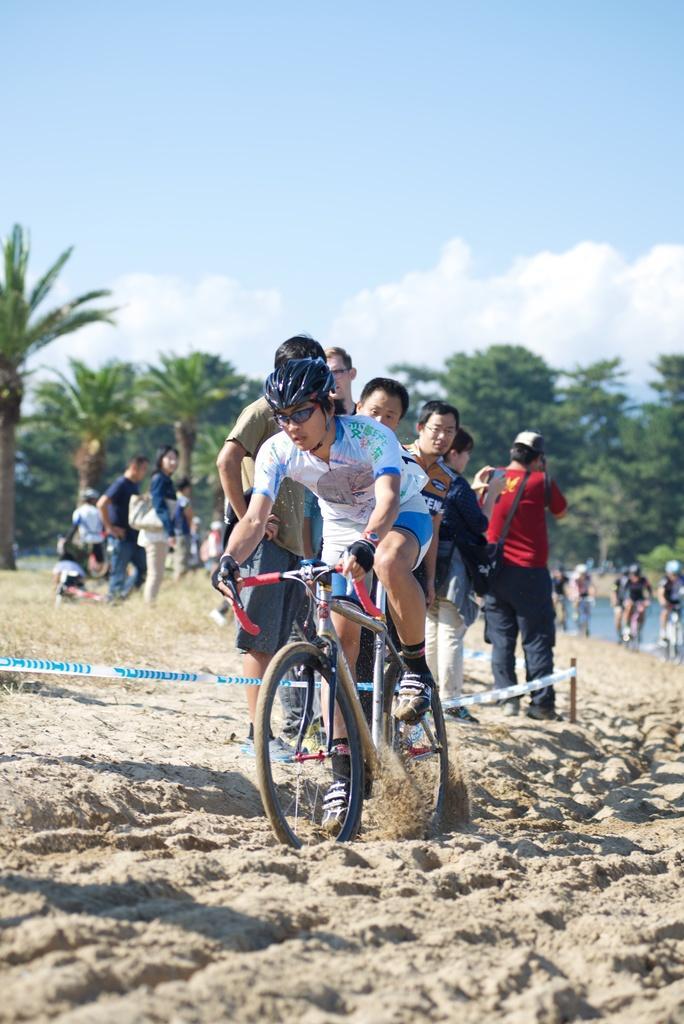Describe this image in one or two sentences. This picture describes about group of people, few are riding bicycles in the sand, and couple of people are watching, in the background we can see couple of trees, water and clouds. 